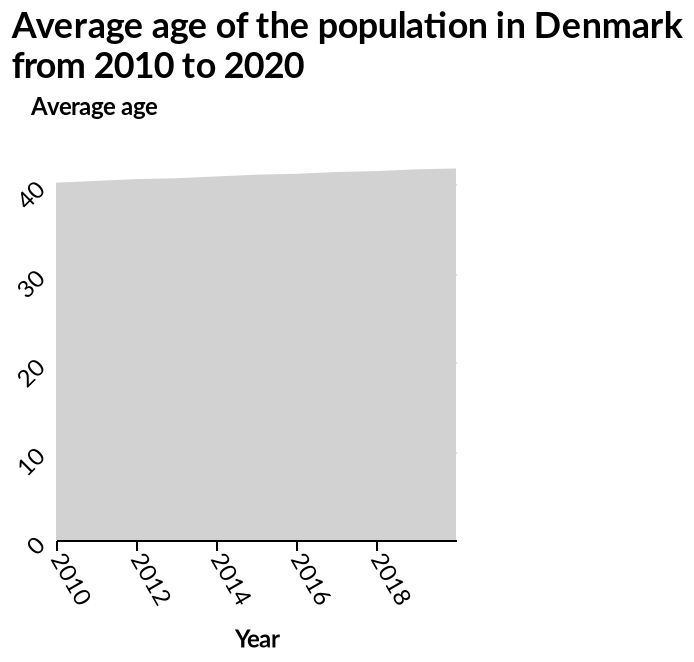<image>
What kind of change is seen in the data? There is a small increase in age after 2018, but other changes are negligible. Can you confidently interpret the visualization?  No, the person is not really sure how to interpret the visualization. please summary the statistics and relations of the chart There is very little change at all. Maybe a small increase in age after 2018. I am not really sure how to interpret this visualization. 